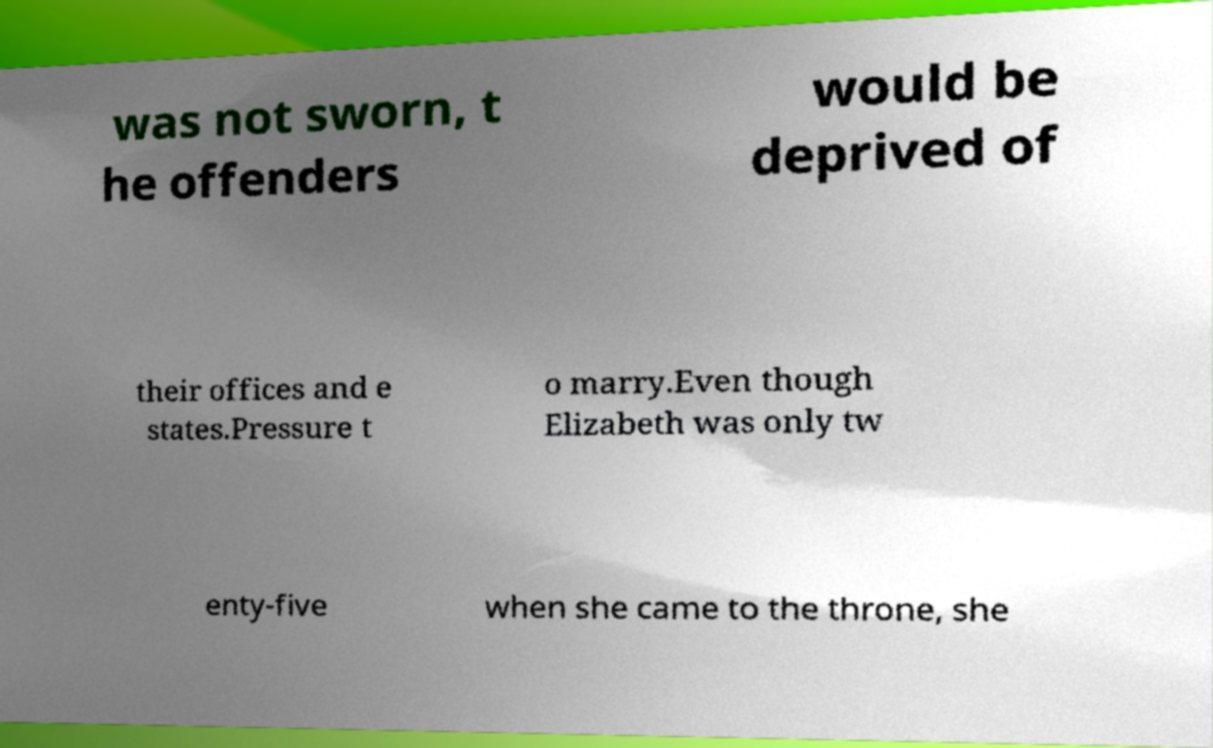Please identify and transcribe the text found in this image. was not sworn, t he offenders would be deprived of their offices and e states.Pressure t o marry.Even though Elizabeth was only tw enty-five when she came to the throne, she 